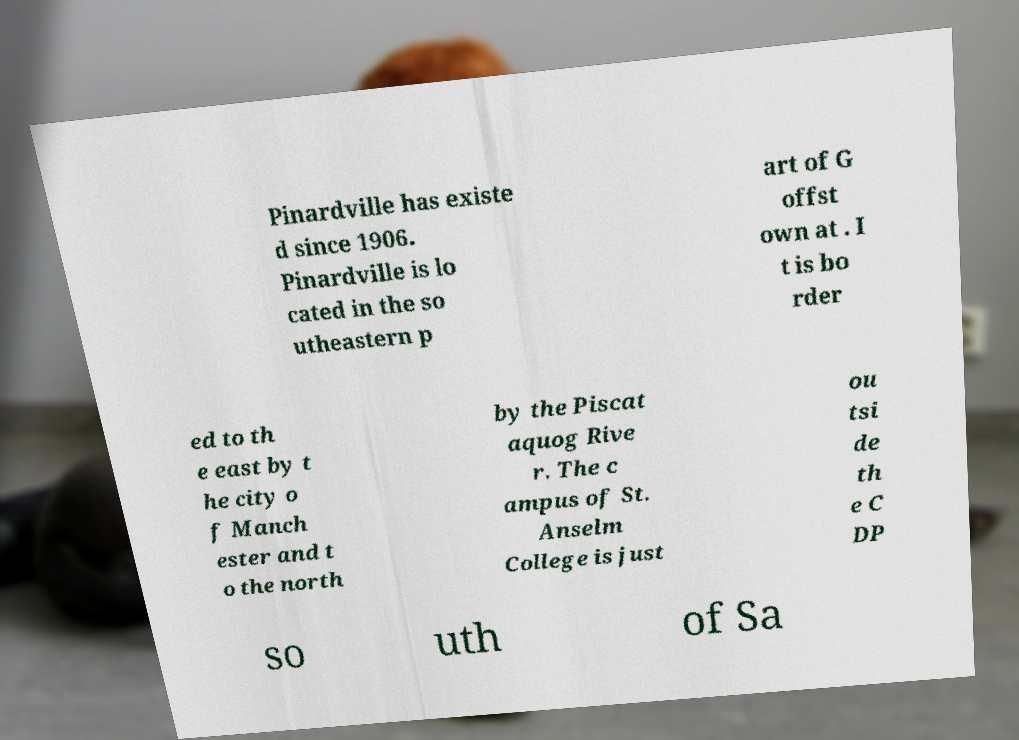I need the written content from this picture converted into text. Can you do that? Pinardville has existe d since 1906. Pinardville is lo cated in the so utheastern p art of G offst own at . I t is bo rder ed to th e east by t he city o f Manch ester and t o the north by the Piscat aquog Rive r. The c ampus of St. Anselm College is just ou tsi de th e C DP so uth of Sa 